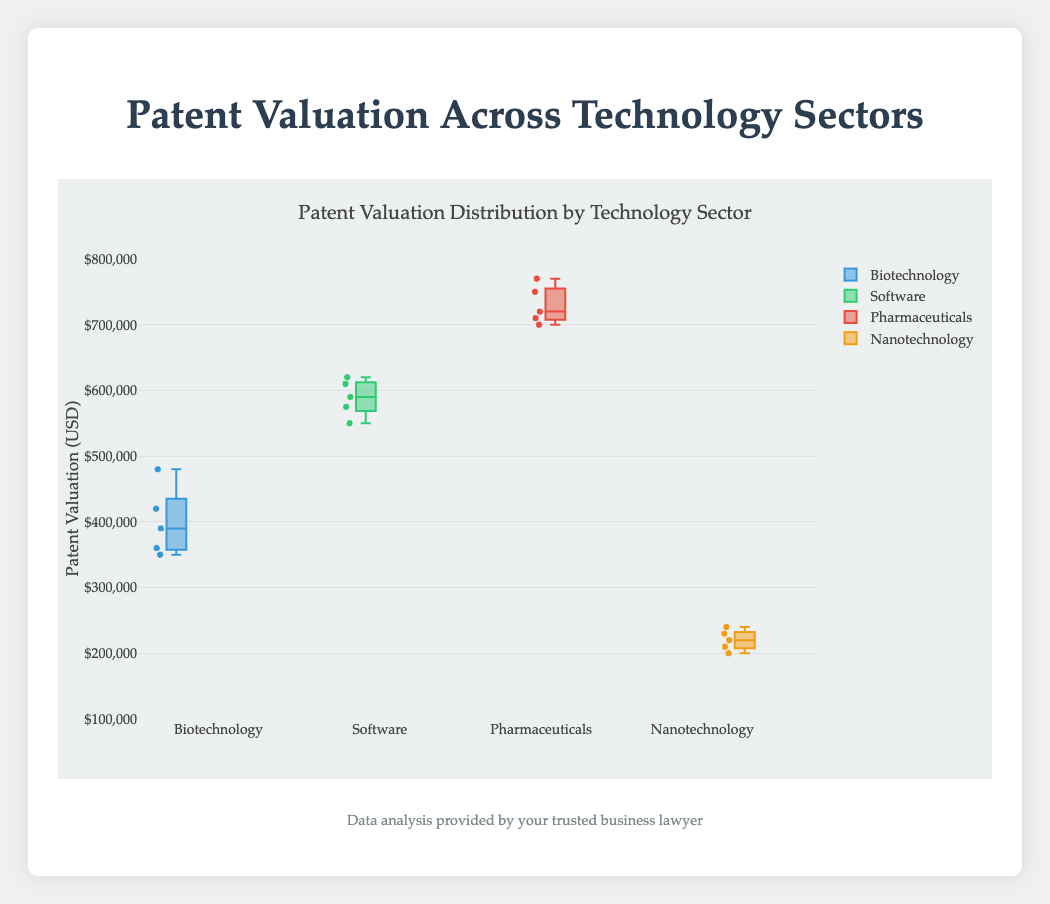What is the title of the box plot? The title of the box plot is displayed at the top of the figure, summarizing what the plot represents. By reading the title, one can understand the subject of the data visualization.
Answer: Patent Valuation Distribution by Technology Sector Which technology sector has the highest median patent valuation? By examining the central line within each box in the box plot, which represents the median, we can compare the sectors. The box plot with the highest central line indicates the highest median valuation.
Answer: Pharmaceuticals How many technology sectors are compared in this box plot? The number of distinct boxes (each labelled with a sector name) in the box plot shows the total technology sectors compared.
Answer: Four What is the range of patent valuations for the Nanotechnology sector? The range within each sector is represented by the vertical span of the boxes including whiskers. For Nanotechnology, this spans from the minimum whisker to the maximum whisker.
Answer: $200,000 to $240,000 Which technology sector shows the greatest variability in patent valuations? Variability is indicated by the height of the boxes and the length of the whiskers. The sector with the largest height depicts the greatest variability.
Answer: Software Which sector's patents have the highest overall maximum valuation? The overall maximum valuation is represented by the highest point above any box. By identifying the highest whisker or point, we find the sector with the highest valuation.
Answer: Pharmaceuticals What is the interquartile range (IQR) for the Software sector? The interquartile range (IQR) is calculated as the distance between the 75th percentile (top edge of the box) and the 25th percentile (bottom edge of the box). For Software, these points can be visually identified and subtracted.
Answer: $575,000 - $550,000 = $25,000 How does the median patent valuation for Biotechnology compare to that of Nanotechnology? The median valuation, indicated by the central line within each box, for Biotechnology and Nanotechnology can be directly compared by their vertical positions in the plot.
Answer: Biotechnology has a higher median than Nanotechnology Which sector has the smallest interquartile range (IQR)? The IQR represents the "depth" of the box. The sector with the smallest height of the box depicts the smallest IQR.
Answer: Nanotechnology What is the approximate median patent valuation for the Software sector? The median is visually identified as the line within the Software box. By reading the position of this line against the scale on the y-axis, the median can be estimated.
Answer: Around $590,000 